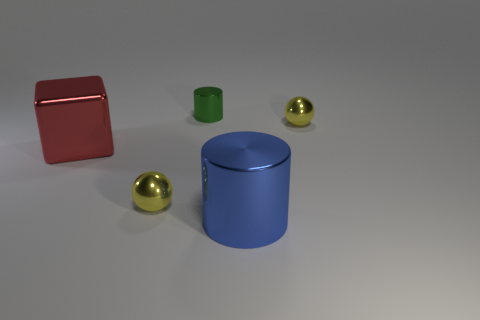Are there fewer large purple balls than big red shiny blocks? It appears that there are no large purple balls present at all, while there is one large red shiny block. So, to answer your question, yes, there are fewer large purple balls than big red shiny blocks because there are none. 